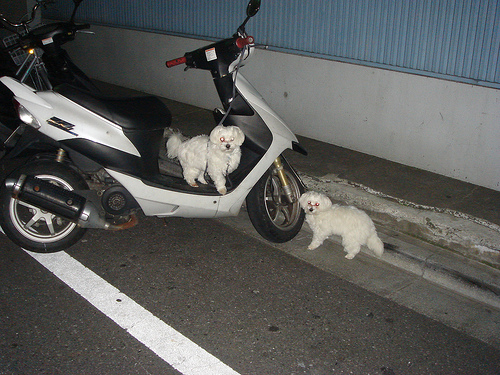What details can you provide about the setting in which this motorcycle and its furry companions are located? The motorcycle is parked in a dimly lit area, likely a parking garage or covered space, evidenced by the shadows and artificial lighting. The concrete flooring and the wall's texture suggest a utilitarian space primarily designed for vehicle accommodation. The presence of the dogs adds life and an interesting twist to this otherwise mundane urban setting. 